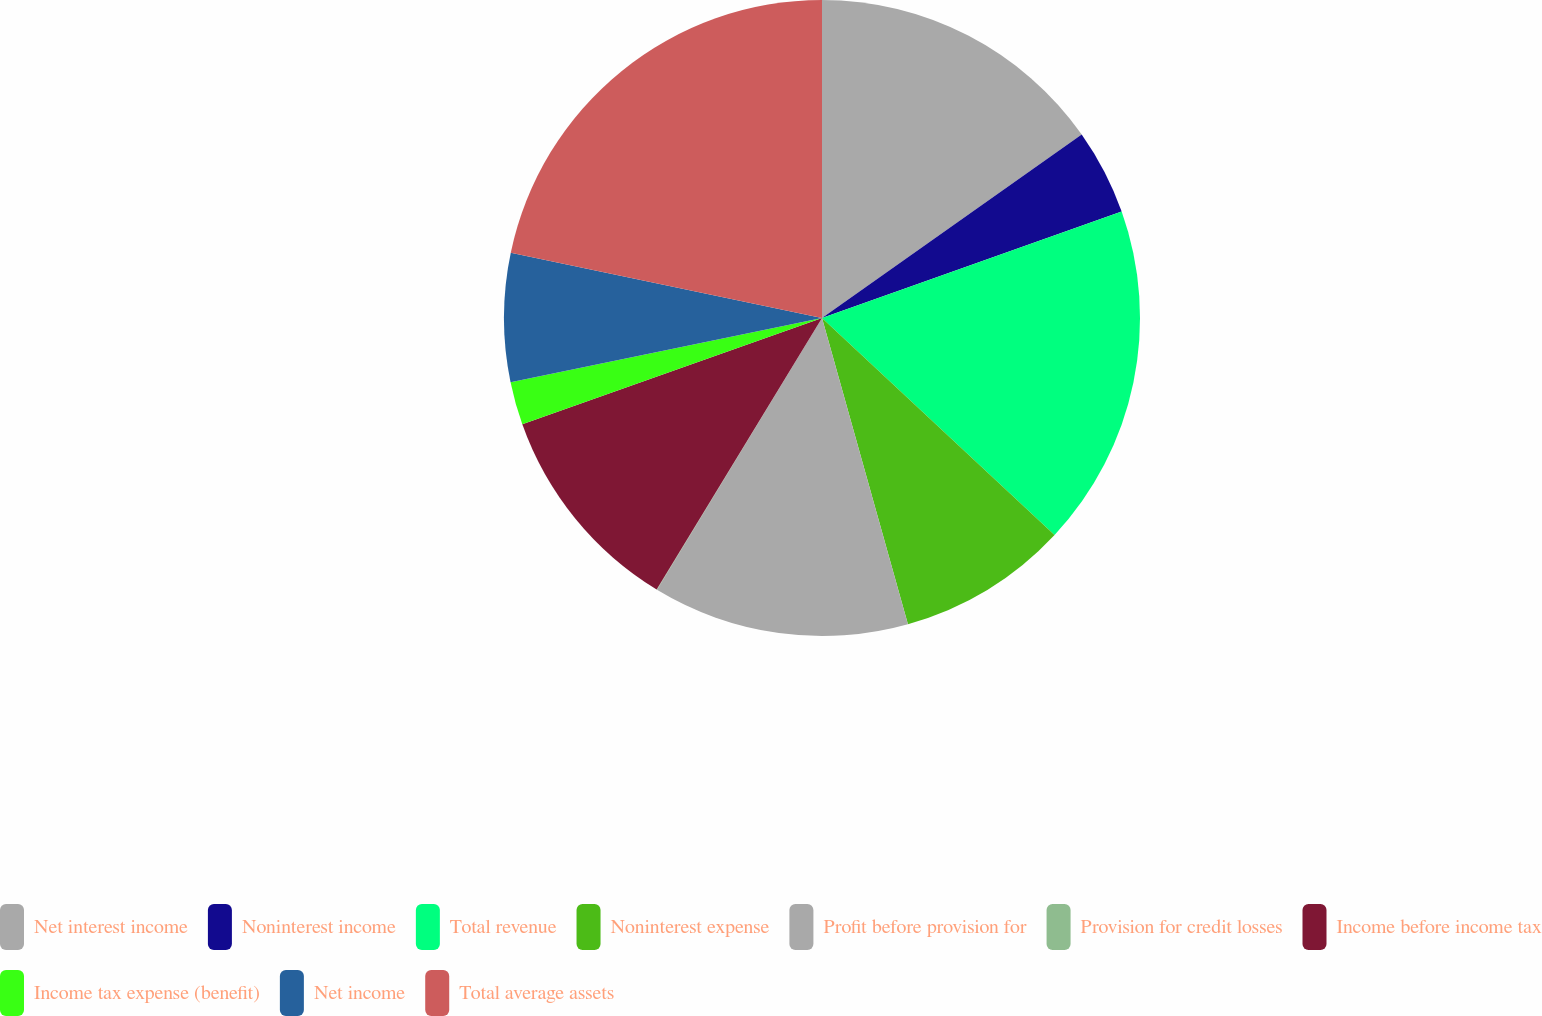Convert chart to OTSL. <chart><loc_0><loc_0><loc_500><loc_500><pie_chart><fcel>Net interest income<fcel>Noninterest income<fcel>Total revenue<fcel>Noninterest expense<fcel>Profit before provision for<fcel>Provision for credit losses<fcel>Income before income tax<fcel>Income tax expense (benefit)<fcel>Net income<fcel>Total average assets<nl><fcel>15.21%<fcel>4.36%<fcel>17.38%<fcel>8.7%<fcel>13.04%<fcel>0.02%<fcel>10.87%<fcel>2.19%<fcel>6.53%<fcel>21.71%<nl></chart> 